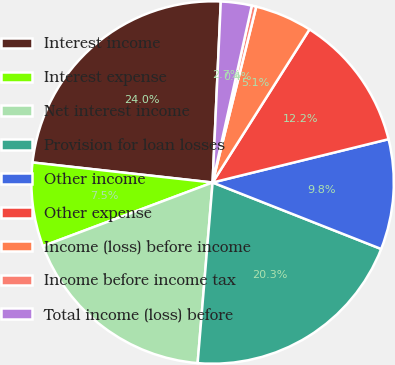<chart> <loc_0><loc_0><loc_500><loc_500><pie_chart><fcel>Interest income<fcel>Interest expense<fcel>Net interest income<fcel>Provision for loan losses<fcel>Other income<fcel>Other expense<fcel>Income (loss) before income<fcel>Income before income tax<fcel>Total income (loss) before<nl><fcel>23.96%<fcel>7.47%<fcel>17.98%<fcel>20.34%<fcel>9.82%<fcel>12.18%<fcel>5.11%<fcel>0.4%<fcel>2.75%<nl></chart> 